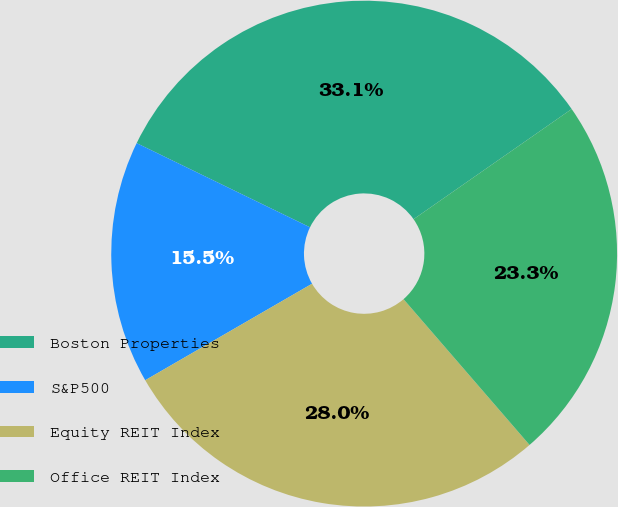<chart> <loc_0><loc_0><loc_500><loc_500><pie_chart><fcel>Boston Properties<fcel>S&P500<fcel>Equity REIT Index<fcel>Office REIT Index<nl><fcel>33.12%<fcel>15.54%<fcel>28.0%<fcel>23.34%<nl></chart> 